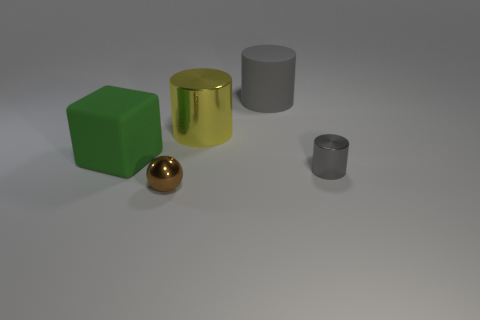Is there a thing of the same color as the sphere?
Provide a short and direct response. No. The yellow metallic thing that is the same size as the green matte object is what shape?
Make the answer very short. Cylinder. Are there any tiny metallic cylinders to the left of the green thing?
Your answer should be compact. No. Is the material of the gray object left of the small gray metallic object the same as the large thing that is on the left side of the tiny brown metallic thing?
Offer a terse response. Yes. What number of metal cylinders have the same size as the ball?
Your answer should be compact. 1. There is a big rubber thing that is the same color as the small cylinder; what shape is it?
Your answer should be compact. Cylinder. What is the gray cylinder in front of the big green object made of?
Offer a very short reply. Metal. How many large yellow objects have the same shape as the gray metal object?
Provide a succinct answer. 1. The thing that is made of the same material as the green block is what shape?
Provide a short and direct response. Cylinder. What shape is the big rubber thing in front of the metal thing behind the rubber object that is left of the brown shiny object?
Make the answer very short. Cube. 